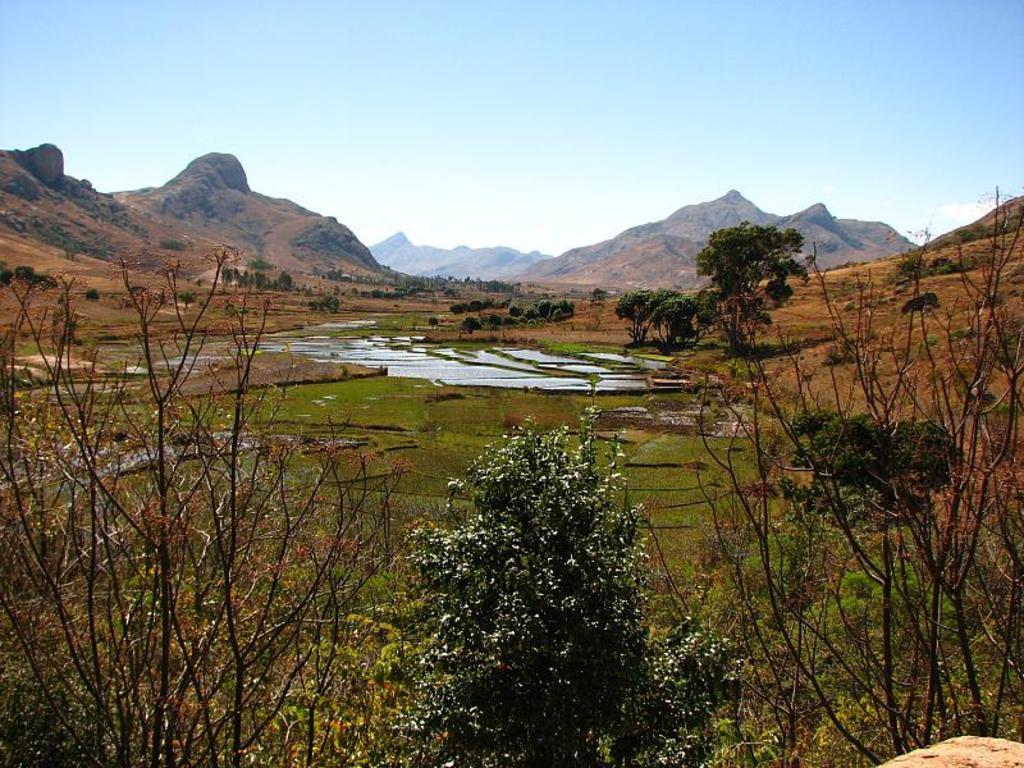Describe this image in one or two sentences. In this picture I can see the farm land, water, trees, plants and grass. In the background I can see the mountains. 